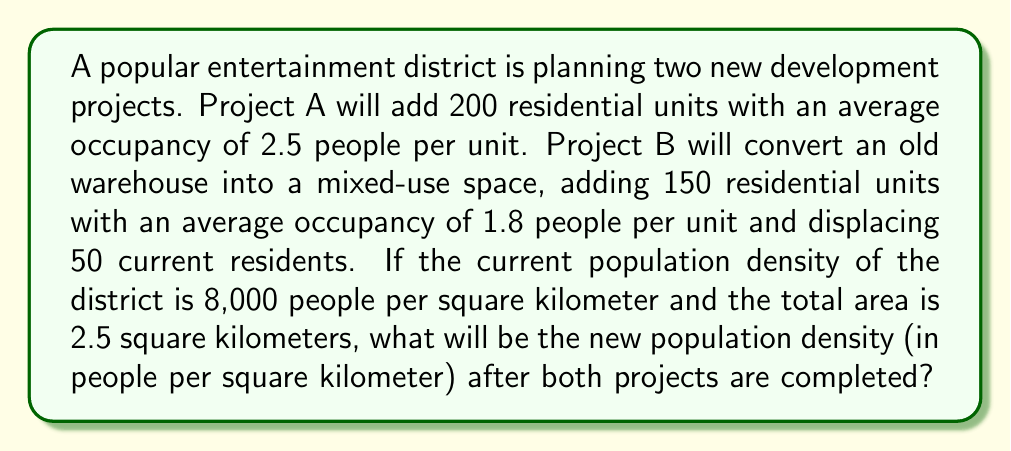Teach me how to tackle this problem. Let's approach this step-by-step:

1. Calculate the current population:
   Current population = Current density × Area
   $$ 8,000 \frac{\text{people}}{\text{km}^2} \times 2.5 \text{ km}^2 = 20,000 \text{ people} $$

2. Calculate the population increase from Project A:
   $$ 200 \text{ units} \times 2.5 \frac{\text{people}}{\text{unit}} = 500 \text{ people} $$

3. Calculate the net population change from Project B:
   New residents: $150 \text{ units} \times 1.8 \frac{\text{people}}{\text{unit}} = 270 \text{ people}$
   Displaced residents: $50 \text{ people}$
   Net change: $270 - 50 = 220 \text{ people}$

4. Calculate the total population increase:
   $$ 500 + 220 = 720 \text{ people} $$

5. Calculate the new total population:
   $$ 20,000 + 720 = 20,720 \text{ people} $$

6. Calculate the new population density:
   $$ \text{New density} = \frac{\text{New population}}{\text{Area}} = \frac{20,720 \text{ people}}{2.5 \text{ km}^2} = 8,288 \frac{\text{people}}{\text{km}^2} $$
Answer: 8,288 people/km² 